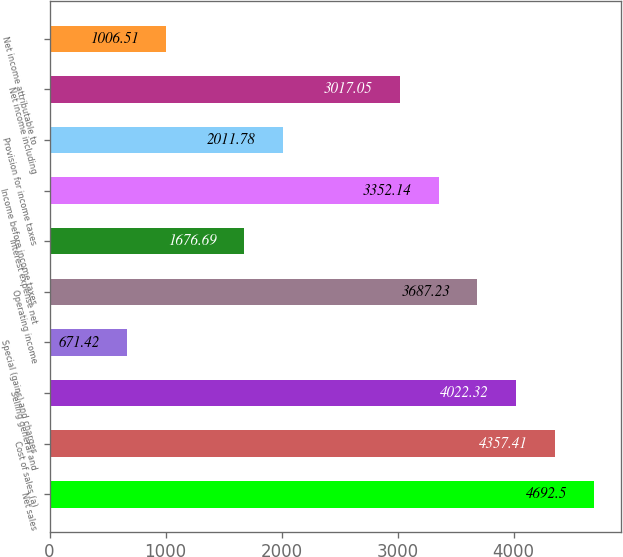Convert chart to OTSL. <chart><loc_0><loc_0><loc_500><loc_500><bar_chart><fcel>Net sales<fcel>Cost of sales (a)<fcel>Selling general and<fcel>Special (gains) and charges<fcel>Operating income<fcel>Interest expense net<fcel>Income before income taxes<fcel>Provision for income taxes<fcel>Net income including<fcel>Net income attributable to<nl><fcel>4692.5<fcel>4357.41<fcel>4022.32<fcel>671.42<fcel>3687.23<fcel>1676.69<fcel>3352.14<fcel>2011.78<fcel>3017.05<fcel>1006.51<nl></chart> 